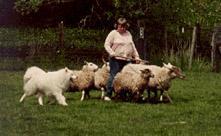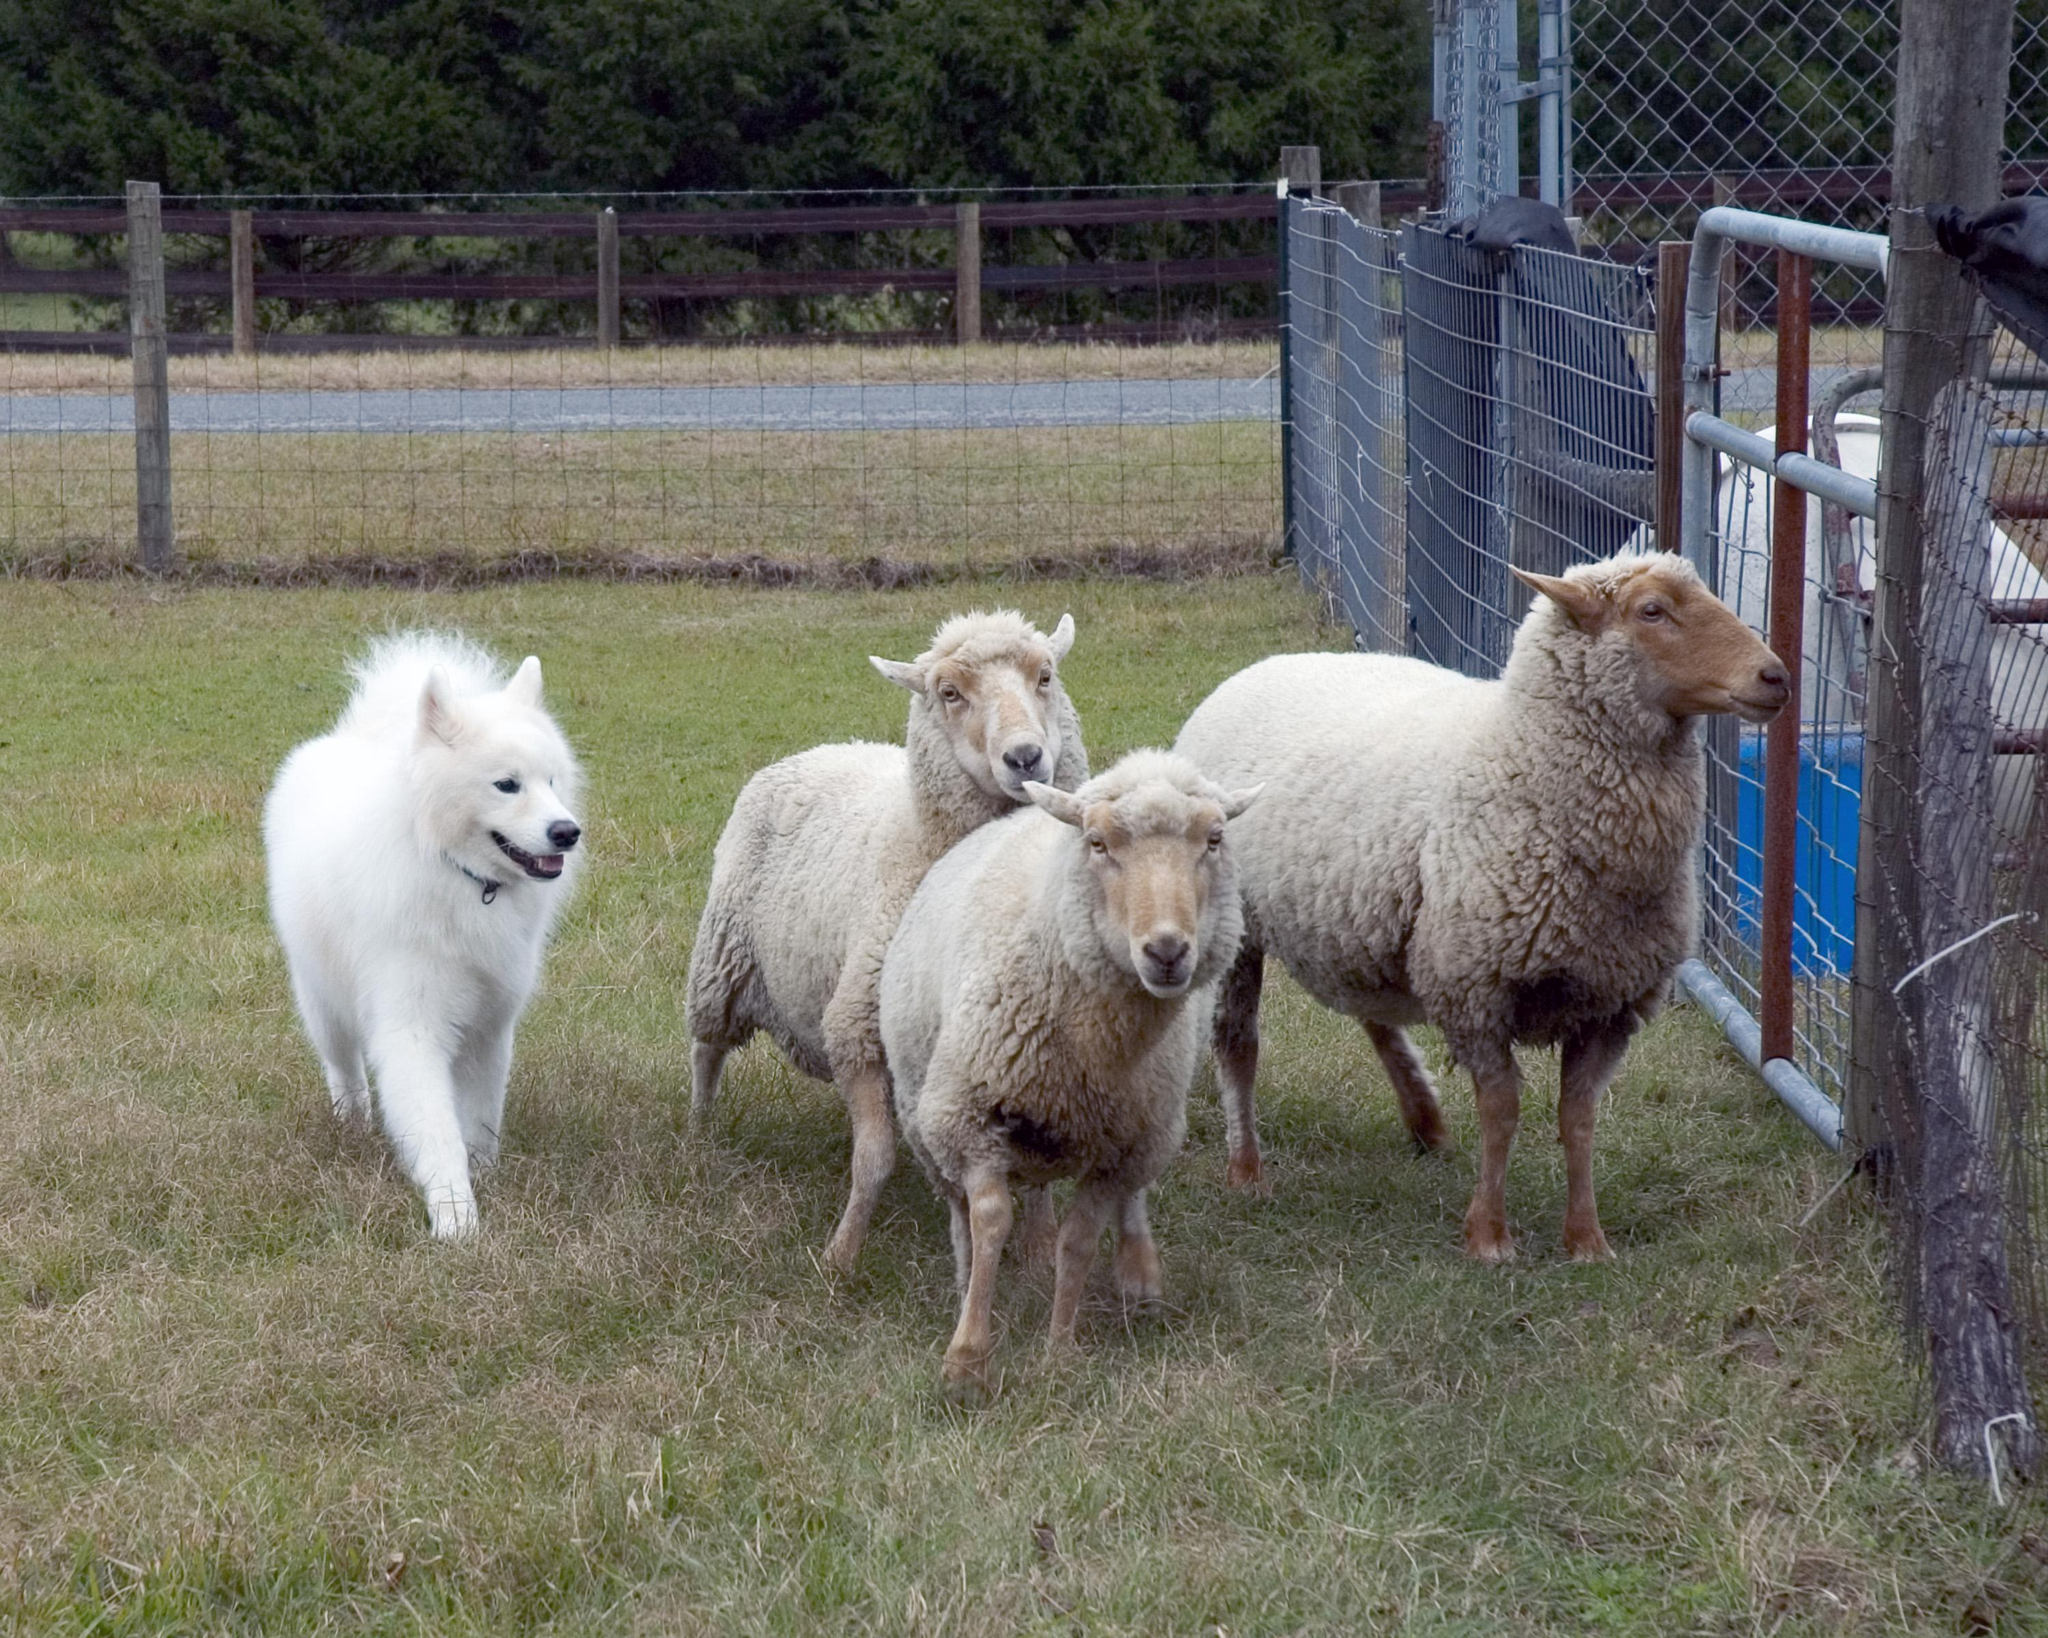The first image is the image on the left, the second image is the image on the right. Analyze the images presented: Is the assertion "There is a woman standing and facing right." valid? Answer yes or no. No. The first image is the image on the left, the second image is the image on the right. Evaluate the accuracy of this statement regarding the images: "In one image, a dog is with a person and sheep.". Is it true? Answer yes or no. Yes. 